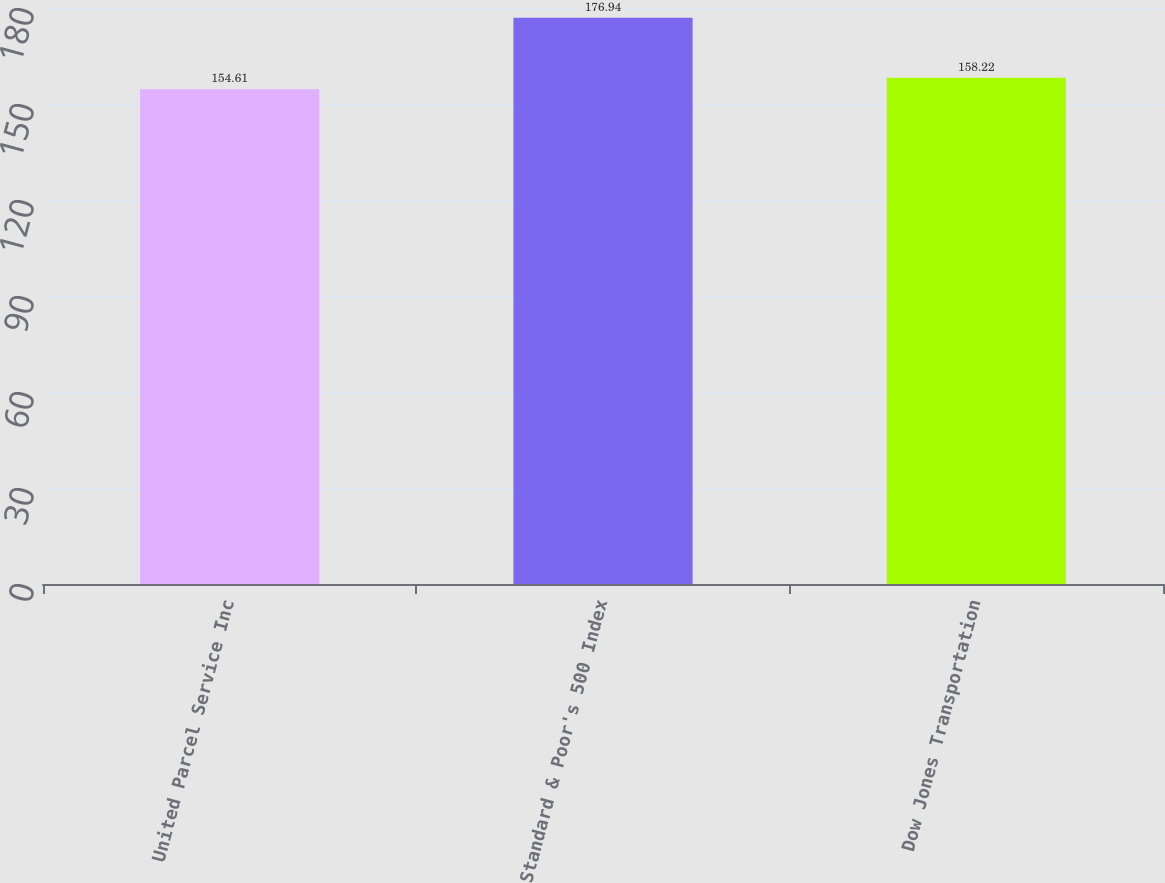Convert chart to OTSL. <chart><loc_0><loc_0><loc_500><loc_500><bar_chart><fcel>United Parcel Service Inc<fcel>Standard & Poor's 500 Index<fcel>Dow Jones Transportation<nl><fcel>154.61<fcel>176.94<fcel>158.22<nl></chart> 